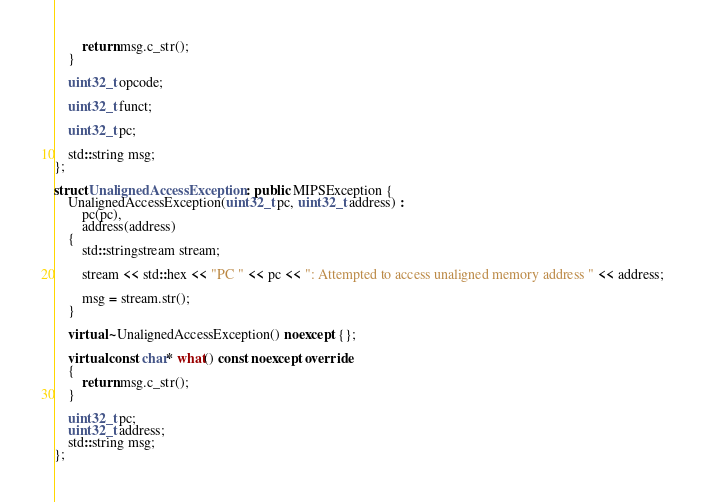Convert code to text. <code><loc_0><loc_0><loc_500><loc_500><_C++_>        return msg.c_str();
    }

    uint32_t opcode;

    uint32_t funct;

    uint32_t pc;

    std::string msg;
};

struct UnalignedAccessException : public MIPSException {
    UnalignedAccessException(uint32_t pc, uint32_t address) :
        pc(pc),
        address(address)
    {
        std::stringstream stream;

        stream << std::hex << "PC " << pc << ": Attempted to access unaligned memory address " << address;

        msg = stream.str();
    }

    virtual ~UnalignedAccessException() noexcept {};

    virtual const char* what() const noexcept override
    {
        return msg.c_str();
    }

    uint32_t pc;
    uint32_t address;
    std::string msg;
};
</code> 